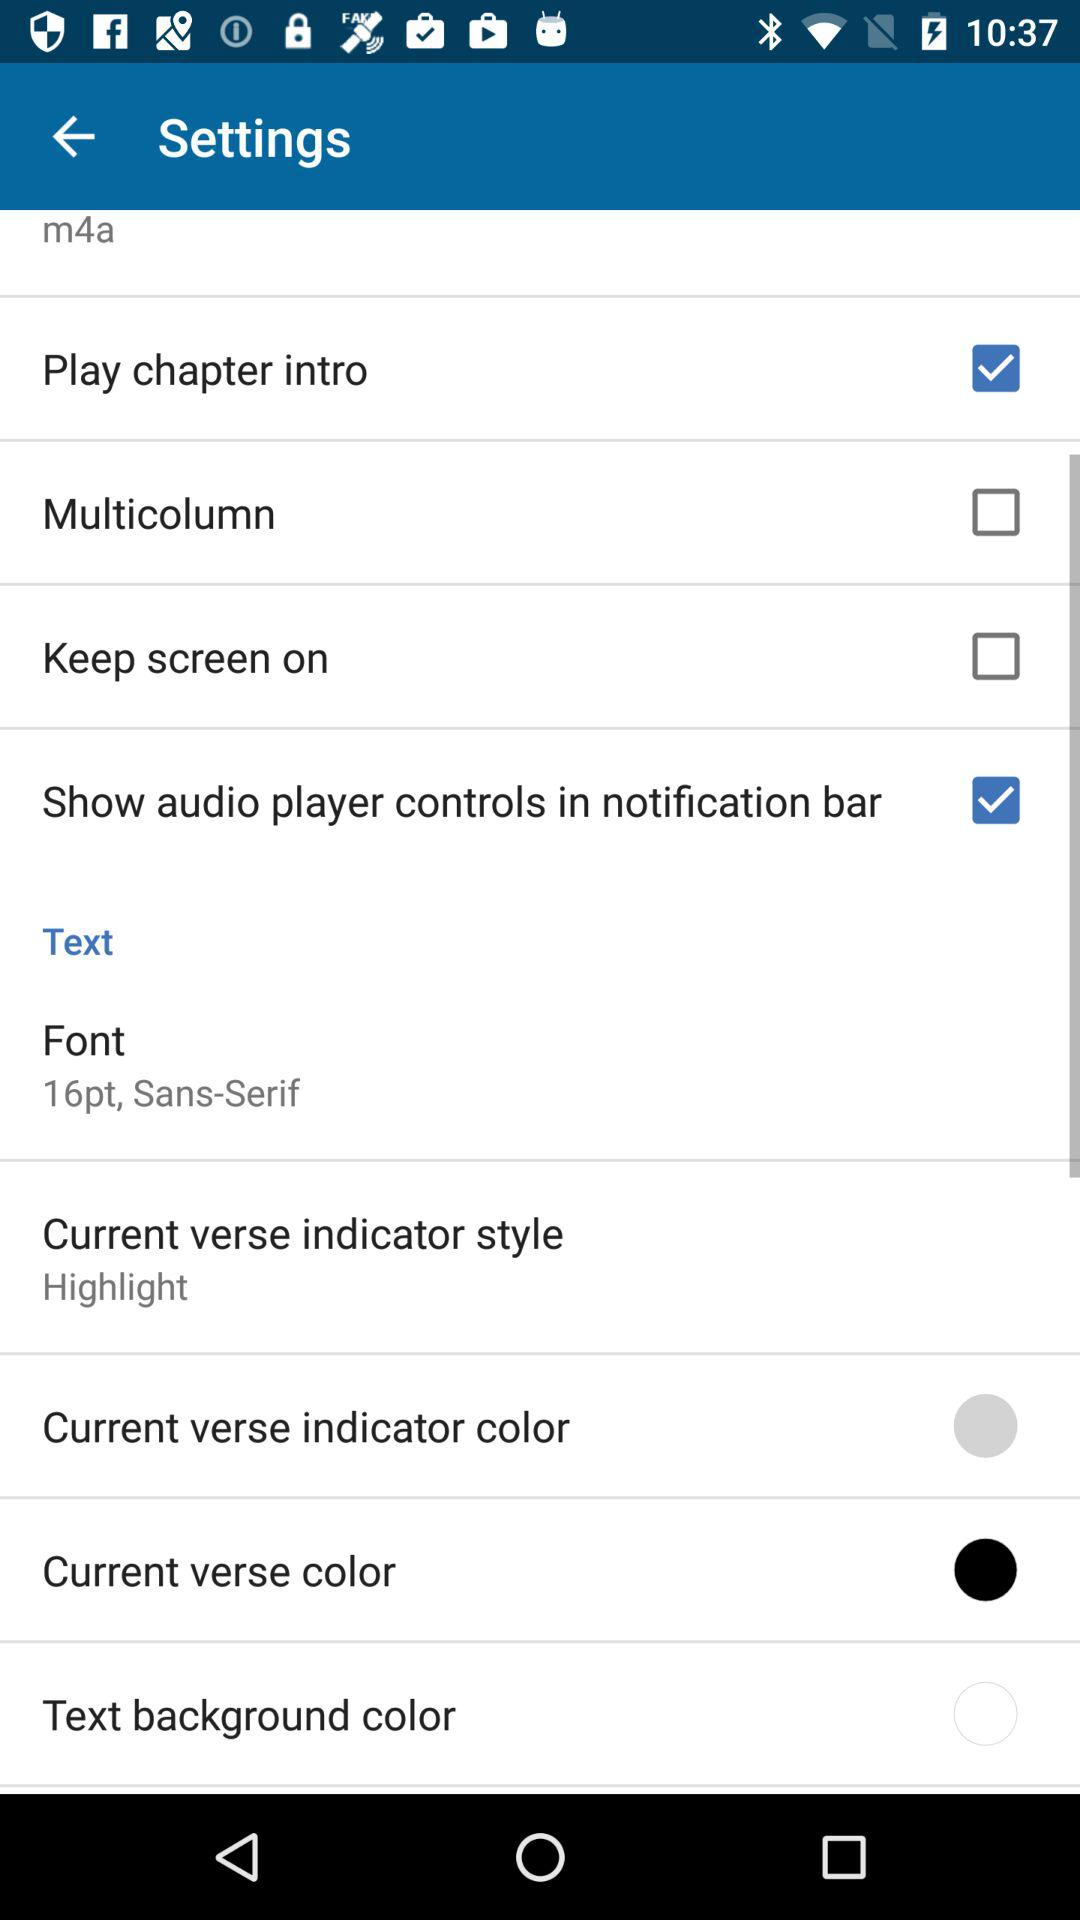What is the current status of the "Play chapter intro"? The current status is on. 